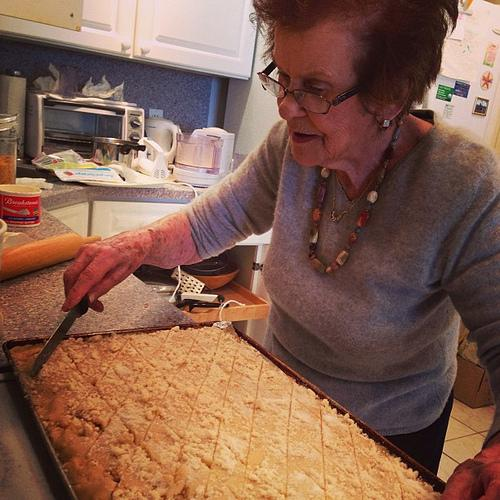What is the woman in the image wearing and holding? The woman is wearing a gray shirt, eyeglasses, earrings, two necklaces, and holding a knife. Can you name some objects present in the background of the image? A toaster oven, wooden rolling pin, paper towels, white cabinets, and a bowl on the shelf are in the background. Are there any other items on the counter besides the tray of pastries? Yes, a mixer, wooden roller, food processor, and a roll of paper towels are on the counter. Provide a short description of the woman's appearance. The woman is wearing a gray shirt, glasses, two necklaces, and earrings, and has part of her hair visible. How can the eyeglasses in the image be described? The eyeglasses are a pair of brown rectangular frames. What kind of dessert is the woman slicing? She is slicing a diagonally cut pastry on a tray. In what way is the woman interacting with the dessert? The woman is cutting the dessert with a knife in her hand. In terms of objects and details, what makes this scene a kitchen? The presence of cabinets, counter, kitchen appliances, utensils, and food items indicate this scene is a kitchen. Please list the colors present in one of the necklaces. The necklace has green, brown, and white beads. What is the primary action taking place in the image? A woman is slicing a dessert in her kitchen. 